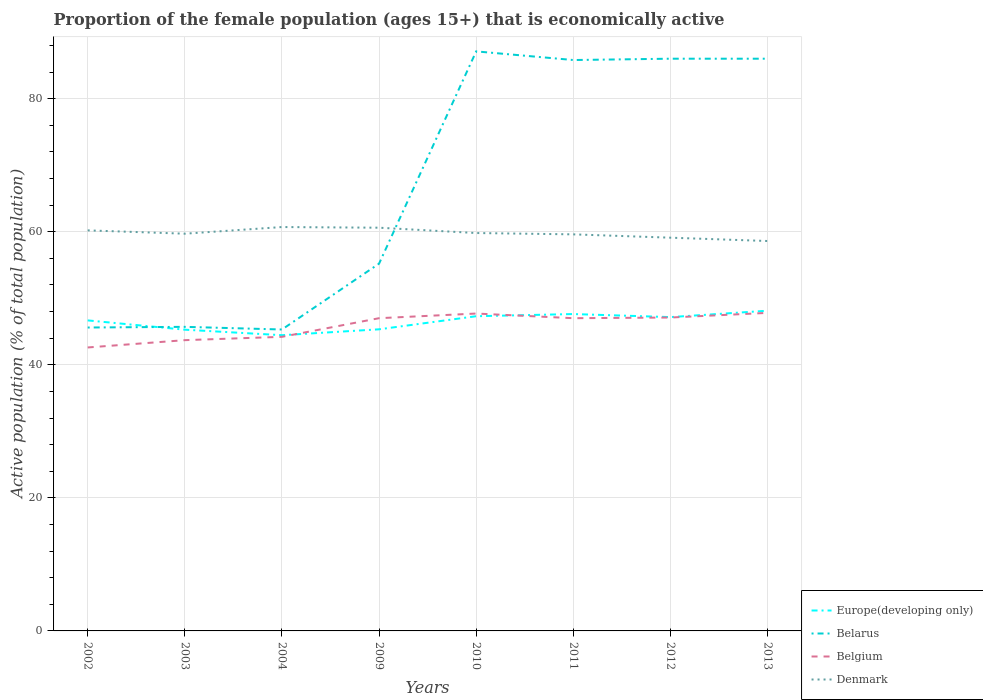Is the number of lines equal to the number of legend labels?
Your response must be concise. Yes. Across all years, what is the maximum proportion of the female population that is economically active in Denmark?
Your response must be concise. 58.6. In which year was the proportion of the female population that is economically active in Europe(developing only) maximum?
Your answer should be compact. 2004. What is the total proportion of the female population that is economically active in Denmark in the graph?
Offer a very short reply. 1.6. What is the difference between the highest and the second highest proportion of the female population that is economically active in Denmark?
Your response must be concise. 2.1. Is the proportion of the female population that is economically active in Belarus strictly greater than the proportion of the female population that is economically active in Denmark over the years?
Your answer should be compact. No. What is the difference between two consecutive major ticks on the Y-axis?
Ensure brevity in your answer.  20. Does the graph contain grids?
Provide a short and direct response. Yes. What is the title of the graph?
Provide a short and direct response. Proportion of the female population (ages 15+) that is economically active. Does "Germany" appear as one of the legend labels in the graph?
Keep it short and to the point. No. What is the label or title of the Y-axis?
Offer a terse response. Active population (% of total population). What is the Active population (% of total population) of Europe(developing only) in 2002?
Keep it short and to the point. 46.67. What is the Active population (% of total population) of Belarus in 2002?
Offer a very short reply. 45.6. What is the Active population (% of total population) in Belgium in 2002?
Offer a very short reply. 42.6. What is the Active population (% of total population) in Denmark in 2002?
Provide a short and direct response. 60.2. What is the Active population (% of total population) of Europe(developing only) in 2003?
Give a very brief answer. 45.27. What is the Active population (% of total population) of Belarus in 2003?
Provide a short and direct response. 45.7. What is the Active population (% of total population) in Belgium in 2003?
Offer a terse response. 43.7. What is the Active population (% of total population) of Denmark in 2003?
Your response must be concise. 59.7. What is the Active population (% of total population) in Europe(developing only) in 2004?
Make the answer very short. 44.45. What is the Active population (% of total population) in Belarus in 2004?
Offer a terse response. 45.3. What is the Active population (% of total population) of Belgium in 2004?
Your answer should be compact. 44.2. What is the Active population (% of total population) in Denmark in 2004?
Your answer should be very brief. 60.7. What is the Active population (% of total population) of Europe(developing only) in 2009?
Your response must be concise. 45.33. What is the Active population (% of total population) of Belarus in 2009?
Offer a very short reply. 55.2. What is the Active population (% of total population) in Denmark in 2009?
Provide a short and direct response. 60.6. What is the Active population (% of total population) in Europe(developing only) in 2010?
Offer a terse response. 47.3. What is the Active population (% of total population) in Belarus in 2010?
Offer a terse response. 87.1. What is the Active population (% of total population) of Belgium in 2010?
Your answer should be very brief. 47.7. What is the Active population (% of total population) in Denmark in 2010?
Your answer should be compact. 59.8. What is the Active population (% of total population) of Europe(developing only) in 2011?
Your answer should be compact. 47.62. What is the Active population (% of total population) in Belarus in 2011?
Provide a succinct answer. 85.8. What is the Active population (% of total population) of Belgium in 2011?
Ensure brevity in your answer.  47. What is the Active population (% of total population) of Denmark in 2011?
Make the answer very short. 59.6. What is the Active population (% of total population) of Europe(developing only) in 2012?
Make the answer very short. 47.16. What is the Active population (% of total population) of Belarus in 2012?
Offer a very short reply. 86. What is the Active population (% of total population) in Belgium in 2012?
Keep it short and to the point. 47.1. What is the Active population (% of total population) of Denmark in 2012?
Provide a succinct answer. 59.1. What is the Active population (% of total population) of Europe(developing only) in 2013?
Offer a very short reply. 48.12. What is the Active population (% of total population) of Belarus in 2013?
Keep it short and to the point. 86. What is the Active population (% of total population) in Belgium in 2013?
Give a very brief answer. 47.8. What is the Active population (% of total population) in Denmark in 2013?
Make the answer very short. 58.6. Across all years, what is the maximum Active population (% of total population) of Europe(developing only)?
Make the answer very short. 48.12. Across all years, what is the maximum Active population (% of total population) in Belarus?
Your response must be concise. 87.1. Across all years, what is the maximum Active population (% of total population) of Belgium?
Give a very brief answer. 47.8. Across all years, what is the maximum Active population (% of total population) of Denmark?
Your answer should be compact. 60.7. Across all years, what is the minimum Active population (% of total population) of Europe(developing only)?
Provide a short and direct response. 44.45. Across all years, what is the minimum Active population (% of total population) in Belarus?
Keep it short and to the point. 45.3. Across all years, what is the minimum Active population (% of total population) in Belgium?
Offer a terse response. 42.6. Across all years, what is the minimum Active population (% of total population) of Denmark?
Provide a succinct answer. 58.6. What is the total Active population (% of total population) of Europe(developing only) in the graph?
Give a very brief answer. 371.93. What is the total Active population (% of total population) in Belarus in the graph?
Make the answer very short. 536.7. What is the total Active population (% of total population) of Belgium in the graph?
Give a very brief answer. 367.1. What is the total Active population (% of total population) of Denmark in the graph?
Offer a terse response. 478.3. What is the difference between the Active population (% of total population) in Europe(developing only) in 2002 and that in 2003?
Ensure brevity in your answer.  1.4. What is the difference between the Active population (% of total population) in Belgium in 2002 and that in 2003?
Keep it short and to the point. -1.1. What is the difference between the Active population (% of total population) in Europe(developing only) in 2002 and that in 2004?
Keep it short and to the point. 2.22. What is the difference between the Active population (% of total population) of Belgium in 2002 and that in 2004?
Provide a succinct answer. -1.6. What is the difference between the Active population (% of total population) of Denmark in 2002 and that in 2004?
Offer a terse response. -0.5. What is the difference between the Active population (% of total population) of Europe(developing only) in 2002 and that in 2009?
Provide a succinct answer. 1.34. What is the difference between the Active population (% of total population) in Belarus in 2002 and that in 2009?
Your answer should be compact. -9.6. What is the difference between the Active population (% of total population) of Denmark in 2002 and that in 2009?
Offer a very short reply. -0.4. What is the difference between the Active population (% of total population) of Europe(developing only) in 2002 and that in 2010?
Give a very brief answer. -0.63. What is the difference between the Active population (% of total population) in Belarus in 2002 and that in 2010?
Offer a very short reply. -41.5. What is the difference between the Active population (% of total population) of Belgium in 2002 and that in 2010?
Provide a short and direct response. -5.1. What is the difference between the Active population (% of total population) in Europe(developing only) in 2002 and that in 2011?
Offer a terse response. -0.95. What is the difference between the Active population (% of total population) in Belarus in 2002 and that in 2011?
Offer a very short reply. -40.2. What is the difference between the Active population (% of total population) in Europe(developing only) in 2002 and that in 2012?
Offer a very short reply. -0.49. What is the difference between the Active population (% of total population) in Belarus in 2002 and that in 2012?
Ensure brevity in your answer.  -40.4. What is the difference between the Active population (% of total population) in Belgium in 2002 and that in 2012?
Provide a succinct answer. -4.5. What is the difference between the Active population (% of total population) in Europe(developing only) in 2002 and that in 2013?
Your response must be concise. -1.46. What is the difference between the Active population (% of total population) of Belarus in 2002 and that in 2013?
Your answer should be very brief. -40.4. What is the difference between the Active population (% of total population) in Europe(developing only) in 2003 and that in 2004?
Your answer should be compact. 0.83. What is the difference between the Active population (% of total population) of Belarus in 2003 and that in 2004?
Give a very brief answer. 0.4. What is the difference between the Active population (% of total population) of Europe(developing only) in 2003 and that in 2009?
Offer a very short reply. -0.06. What is the difference between the Active population (% of total population) in Belarus in 2003 and that in 2009?
Your answer should be very brief. -9.5. What is the difference between the Active population (% of total population) of Belgium in 2003 and that in 2009?
Your response must be concise. -3.3. What is the difference between the Active population (% of total population) in Denmark in 2003 and that in 2009?
Keep it short and to the point. -0.9. What is the difference between the Active population (% of total population) in Europe(developing only) in 2003 and that in 2010?
Your answer should be compact. -2.02. What is the difference between the Active population (% of total population) in Belarus in 2003 and that in 2010?
Your answer should be very brief. -41.4. What is the difference between the Active population (% of total population) in Belgium in 2003 and that in 2010?
Offer a terse response. -4. What is the difference between the Active population (% of total population) in Europe(developing only) in 2003 and that in 2011?
Your answer should be compact. -2.35. What is the difference between the Active population (% of total population) of Belarus in 2003 and that in 2011?
Offer a terse response. -40.1. What is the difference between the Active population (% of total population) of Belgium in 2003 and that in 2011?
Make the answer very short. -3.3. What is the difference between the Active population (% of total population) of Europe(developing only) in 2003 and that in 2012?
Offer a very short reply. -1.89. What is the difference between the Active population (% of total population) of Belarus in 2003 and that in 2012?
Your answer should be compact. -40.3. What is the difference between the Active population (% of total population) in Belgium in 2003 and that in 2012?
Provide a succinct answer. -3.4. What is the difference between the Active population (% of total population) in Europe(developing only) in 2003 and that in 2013?
Make the answer very short. -2.85. What is the difference between the Active population (% of total population) in Belarus in 2003 and that in 2013?
Give a very brief answer. -40.3. What is the difference between the Active population (% of total population) in Belgium in 2003 and that in 2013?
Give a very brief answer. -4.1. What is the difference between the Active population (% of total population) in Europe(developing only) in 2004 and that in 2009?
Offer a terse response. -0.88. What is the difference between the Active population (% of total population) in Denmark in 2004 and that in 2009?
Your answer should be very brief. 0.1. What is the difference between the Active population (% of total population) of Europe(developing only) in 2004 and that in 2010?
Ensure brevity in your answer.  -2.85. What is the difference between the Active population (% of total population) of Belarus in 2004 and that in 2010?
Your answer should be compact. -41.8. What is the difference between the Active population (% of total population) of Belgium in 2004 and that in 2010?
Offer a very short reply. -3.5. What is the difference between the Active population (% of total population) in Europe(developing only) in 2004 and that in 2011?
Keep it short and to the point. -3.18. What is the difference between the Active population (% of total population) of Belarus in 2004 and that in 2011?
Provide a short and direct response. -40.5. What is the difference between the Active population (% of total population) in Denmark in 2004 and that in 2011?
Give a very brief answer. 1.1. What is the difference between the Active population (% of total population) of Europe(developing only) in 2004 and that in 2012?
Keep it short and to the point. -2.72. What is the difference between the Active population (% of total population) in Belarus in 2004 and that in 2012?
Ensure brevity in your answer.  -40.7. What is the difference between the Active population (% of total population) in Belgium in 2004 and that in 2012?
Your response must be concise. -2.9. What is the difference between the Active population (% of total population) of Denmark in 2004 and that in 2012?
Make the answer very short. 1.6. What is the difference between the Active population (% of total population) of Europe(developing only) in 2004 and that in 2013?
Your answer should be compact. -3.68. What is the difference between the Active population (% of total population) in Belarus in 2004 and that in 2013?
Your answer should be compact. -40.7. What is the difference between the Active population (% of total population) in Denmark in 2004 and that in 2013?
Give a very brief answer. 2.1. What is the difference between the Active population (% of total population) of Europe(developing only) in 2009 and that in 2010?
Provide a succinct answer. -1.97. What is the difference between the Active population (% of total population) in Belarus in 2009 and that in 2010?
Ensure brevity in your answer.  -31.9. What is the difference between the Active population (% of total population) in Denmark in 2009 and that in 2010?
Make the answer very short. 0.8. What is the difference between the Active population (% of total population) in Europe(developing only) in 2009 and that in 2011?
Provide a succinct answer. -2.29. What is the difference between the Active population (% of total population) in Belarus in 2009 and that in 2011?
Give a very brief answer. -30.6. What is the difference between the Active population (% of total population) in Denmark in 2009 and that in 2011?
Make the answer very short. 1. What is the difference between the Active population (% of total population) of Europe(developing only) in 2009 and that in 2012?
Offer a terse response. -1.83. What is the difference between the Active population (% of total population) in Belarus in 2009 and that in 2012?
Your response must be concise. -30.8. What is the difference between the Active population (% of total population) in Europe(developing only) in 2009 and that in 2013?
Your answer should be very brief. -2.79. What is the difference between the Active population (% of total population) in Belarus in 2009 and that in 2013?
Offer a terse response. -30.8. What is the difference between the Active population (% of total population) in Belgium in 2009 and that in 2013?
Provide a succinct answer. -0.8. What is the difference between the Active population (% of total population) in Denmark in 2009 and that in 2013?
Your response must be concise. 2. What is the difference between the Active population (% of total population) of Europe(developing only) in 2010 and that in 2011?
Ensure brevity in your answer.  -0.33. What is the difference between the Active population (% of total population) of Belarus in 2010 and that in 2011?
Ensure brevity in your answer.  1.3. What is the difference between the Active population (% of total population) in Denmark in 2010 and that in 2011?
Offer a terse response. 0.2. What is the difference between the Active population (% of total population) in Europe(developing only) in 2010 and that in 2012?
Offer a terse response. 0.13. What is the difference between the Active population (% of total population) in Belgium in 2010 and that in 2012?
Keep it short and to the point. 0.6. What is the difference between the Active population (% of total population) in Denmark in 2010 and that in 2012?
Ensure brevity in your answer.  0.7. What is the difference between the Active population (% of total population) of Europe(developing only) in 2010 and that in 2013?
Your answer should be compact. -0.83. What is the difference between the Active population (% of total population) in Belarus in 2010 and that in 2013?
Provide a short and direct response. 1.1. What is the difference between the Active population (% of total population) of Belgium in 2010 and that in 2013?
Offer a very short reply. -0.1. What is the difference between the Active population (% of total population) in Europe(developing only) in 2011 and that in 2012?
Ensure brevity in your answer.  0.46. What is the difference between the Active population (% of total population) of Belgium in 2011 and that in 2012?
Give a very brief answer. -0.1. What is the difference between the Active population (% of total population) of Europe(developing only) in 2011 and that in 2013?
Provide a succinct answer. -0.5. What is the difference between the Active population (% of total population) of Belarus in 2011 and that in 2013?
Make the answer very short. -0.2. What is the difference between the Active population (% of total population) in Denmark in 2011 and that in 2013?
Ensure brevity in your answer.  1. What is the difference between the Active population (% of total population) in Europe(developing only) in 2012 and that in 2013?
Ensure brevity in your answer.  -0.96. What is the difference between the Active population (% of total population) in Belarus in 2012 and that in 2013?
Ensure brevity in your answer.  0. What is the difference between the Active population (% of total population) of Europe(developing only) in 2002 and the Active population (% of total population) of Belarus in 2003?
Provide a succinct answer. 0.97. What is the difference between the Active population (% of total population) in Europe(developing only) in 2002 and the Active population (% of total population) in Belgium in 2003?
Keep it short and to the point. 2.97. What is the difference between the Active population (% of total population) in Europe(developing only) in 2002 and the Active population (% of total population) in Denmark in 2003?
Provide a short and direct response. -13.03. What is the difference between the Active population (% of total population) in Belarus in 2002 and the Active population (% of total population) in Belgium in 2003?
Your answer should be compact. 1.9. What is the difference between the Active population (% of total population) in Belarus in 2002 and the Active population (% of total population) in Denmark in 2003?
Your answer should be compact. -14.1. What is the difference between the Active population (% of total population) of Belgium in 2002 and the Active population (% of total population) of Denmark in 2003?
Offer a very short reply. -17.1. What is the difference between the Active population (% of total population) of Europe(developing only) in 2002 and the Active population (% of total population) of Belarus in 2004?
Give a very brief answer. 1.37. What is the difference between the Active population (% of total population) of Europe(developing only) in 2002 and the Active population (% of total population) of Belgium in 2004?
Keep it short and to the point. 2.47. What is the difference between the Active population (% of total population) in Europe(developing only) in 2002 and the Active population (% of total population) in Denmark in 2004?
Ensure brevity in your answer.  -14.03. What is the difference between the Active population (% of total population) of Belarus in 2002 and the Active population (% of total population) of Belgium in 2004?
Your answer should be very brief. 1.4. What is the difference between the Active population (% of total population) in Belarus in 2002 and the Active population (% of total population) in Denmark in 2004?
Offer a terse response. -15.1. What is the difference between the Active population (% of total population) in Belgium in 2002 and the Active population (% of total population) in Denmark in 2004?
Provide a succinct answer. -18.1. What is the difference between the Active population (% of total population) in Europe(developing only) in 2002 and the Active population (% of total population) in Belarus in 2009?
Your response must be concise. -8.53. What is the difference between the Active population (% of total population) in Europe(developing only) in 2002 and the Active population (% of total population) in Belgium in 2009?
Make the answer very short. -0.33. What is the difference between the Active population (% of total population) of Europe(developing only) in 2002 and the Active population (% of total population) of Denmark in 2009?
Keep it short and to the point. -13.93. What is the difference between the Active population (% of total population) of Belarus in 2002 and the Active population (% of total population) of Belgium in 2009?
Provide a succinct answer. -1.4. What is the difference between the Active population (% of total population) in Belgium in 2002 and the Active population (% of total population) in Denmark in 2009?
Offer a very short reply. -18. What is the difference between the Active population (% of total population) in Europe(developing only) in 2002 and the Active population (% of total population) in Belarus in 2010?
Offer a terse response. -40.43. What is the difference between the Active population (% of total population) of Europe(developing only) in 2002 and the Active population (% of total population) of Belgium in 2010?
Offer a very short reply. -1.03. What is the difference between the Active population (% of total population) of Europe(developing only) in 2002 and the Active population (% of total population) of Denmark in 2010?
Your response must be concise. -13.13. What is the difference between the Active population (% of total population) of Belarus in 2002 and the Active population (% of total population) of Denmark in 2010?
Provide a succinct answer. -14.2. What is the difference between the Active population (% of total population) in Belgium in 2002 and the Active population (% of total population) in Denmark in 2010?
Provide a succinct answer. -17.2. What is the difference between the Active population (% of total population) in Europe(developing only) in 2002 and the Active population (% of total population) in Belarus in 2011?
Offer a terse response. -39.13. What is the difference between the Active population (% of total population) of Europe(developing only) in 2002 and the Active population (% of total population) of Belgium in 2011?
Your answer should be compact. -0.33. What is the difference between the Active population (% of total population) of Europe(developing only) in 2002 and the Active population (% of total population) of Denmark in 2011?
Give a very brief answer. -12.93. What is the difference between the Active population (% of total population) in Belarus in 2002 and the Active population (% of total population) in Denmark in 2011?
Your answer should be very brief. -14. What is the difference between the Active population (% of total population) of Belgium in 2002 and the Active population (% of total population) of Denmark in 2011?
Keep it short and to the point. -17. What is the difference between the Active population (% of total population) in Europe(developing only) in 2002 and the Active population (% of total population) in Belarus in 2012?
Give a very brief answer. -39.33. What is the difference between the Active population (% of total population) in Europe(developing only) in 2002 and the Active population (% of total population) in Belgium in 2012?
Provide a succinct answer. -0.43. What is the difference between the Active population (% of total population) of Europe(developing only) in 2002 and the Active population (% of total population) of Denmark in 2012?
Your answer should be compact. -12.43. What is the difference between the Active population (% of total population) of Belarus in 2002 and the Active population (% of total population) of Belgium in 2012?
Offer a very short reply. -1.5. What is the difference between the Active population (% of total population) of Belgium in 2002 and the Active population (% of total population) of Denmark in 2012?
Your answer should be very brief. -16.5. What is the difference between the Active population (% of total population) of Europe(developing only) in 2002 and the Active population (% of total population) of Belarus in 2013?
Provide a short and direct response. -39.33. What is the difference between the Active population (% of total population) in Europe(developing only) in 2002 and the Active population (% of total population) in Belgium in 2013?
Provide a succinct answer. -1.13. What is the difference between the Active population (% of total population) of Europe(developing only) in 2002 and the Active population (% of total population) of Denmark in 2013?
Give a very brief answer. -11.93. What is the difference between the Active population (% of total population) of Europe(developing only) in 2003 and the Active population (% of total population) of Belarus in 2004?
Give a very brief answer. -0.03. What is the difference between the Active population (% of total population) in Europe(developing only) in 2003 and the Active population (% of total population) in Belgium in 2004?
Keep it short and to the point. 1.07. What is the difference between the Active population (% of total population) of Europe(developing only) in 2003 and the Active population (% of total population) of Denmark in 2004?
Offer a terse response. -15.43. What is the difference between the Active population (% of total population) in Europe(developing only) in 2003 and the Active population (% of total population) in Belarus in 2009?
Your answer should be very brief. -9.93. What is the difference between the Active population (% of total population) of Europe(developing only) in 2003 and the Active population (% of total population) of Belgium in 2009?
Your answer should be compact. -1.73. What is the difference between the Active population (% of total population) in Europe(developing only) in 2003 and the Active population (% of total population) in Denmark in 2009?
Keep it short and to the point. -15.33. What is the difference between the Active population (% of total population) of Belarus in 2003 and the Active population (% of total population) of Belgium in 2009?
Provide a succinct answer. -1.3. What is the difference between the Active population (% of total population) of Belarus in 2003 and the Active population (% of total population) of Denmark in 2009?
Offer a terse response. -14.9. What is the difference between the Active population (% of total population) of Belgium in 2003 and the Active population (% of total population) of Denmark in 2009?
Ensure brevity in your answer.  -16.9. What is the difference between the Active population (% of total population) of Europe(developing only) in 2003 and the Active population (% of total population) of Belarus in 2010?
Make the answer very short. -41.83. What is the difference between the Active population (% of total population) in Europe(developing only) in 2003 and the Active population (% of total population) in Belgium in 2010?
Offer a very short reply. -2.43. What is the difference between the Active population (% of total population) of Europe(developing only) in 2003 and the Active population (% of total population) of Denmark in 2010?
Provide a succinct answer. -14.53. What is the difference between the Active population (% of total population) of Belarus in 2003 and the Active population (% of total population) of Belgium in 2010?
Offer a terse response. -2. What is the difference between the Active population (% of total population) of Belarus in 2003 and the Active population (% of total population) of Denmark in 2010?
Give a very brief answer. -14.1. What is the difference between the Active population (% of total population) in Belgium in 2003 and the Active population (% of total population) in Denmark in 2010?
Provide a short and direct response. -16.1. What is the difference between the Active population (% of total population) in Europe(developing only) in 2003 and the Active population (% of total population) in Belarus in 2011?
Give a very brief answer. -40.53. What is the difference between the Active population (% of total population) in Europe(developing only) in 2003 and the Active population (% of total population) in Belgium in 2011?
Keep it short and to the point. -1.73. What is the difference between the Active population (% of total population) in Europe(developing only) in 2003 and the Active population (% of total population) in Denmark in 2011?
Your answer should be compact. -14.33. What is the difference between the Active population (% of total population) of Belarus in 2003 and the Active population (% of total population) of Denmark in 2011?
Provide a short and direct response. -13.9. What is the difference between the Active population (% of total population) in Belgium in 2003 and the Active population (% of total population) in Denmark in 2011?
Keep it short and to the point. -15.9. What is the difference between the Active population (% of total population) in Europe(developing only) in 2003 and the Active population (% of total population) in Belarus in 2012?
Ensure brevity in your answer.  -40.73. What is the difference between the Active population (% of total population) in Europe(developing only) in 2003 and the Active population (% of total population) in Belgium in 2012?
Keep it short and to the point. -1.83. What is the difference between the Active population (% of total population) in Europe(developing only) in 2003 and the Active population (% of total population) in Denmark in 2012?
Offer a terse response. -13.83. What is the difference between the Active population (% of total population) of Belarus in 2003 and the Active population (% of total population) of Denmark in 2012?
Offer a terse response. -13.4. What is the difference between the Active population (% of total population) of Belgium in 2003 and the Active population (% of total population) of Denmark in 2012?
Offer a terse response. -15.4. What is the difference between the Active population (% of total population) in Europe(developing only) in 2003 and the Active population (% of total population) in Belarus in 2013?
Your answer should be compact. -40.73. What is the difference between the Active population (% of total population) of Europe(developing only) in 2003 and the Active population (% of total population) of Belgium in 2013?
Offer a terse response. -2.53. What is the difference between the Active population (% of total population) in Europe(developing only) in 2003 and the Active population (% of total population) in Denmark in 2013?
Make the answer very short. -13.33. What is the difference between the Active population (% of total population) of Belarus in 2003 and the Active population (% of total population) of Belgium in 2013?
Your answer should be compact. -2.1. What is the difference between the Active population (% of total population) of Belgium in 2003 and the Active population (% of total population) of Denmark in 2013?
Make the answer very short. -14.9. What is the difference between the Active population (% of total population) of Europe(developing only) in 2004 and the Active population (% of total population) of Belarus in 2009?
Provide a succinct answer. -10.75. What is the difference between the Active population (% of total population) of Europe(developing only) in 2004 and the Active population (% of total population) of Belgium in 2009?
Keep it short and to the point. -2.55. What is the difference between the Active population (% of total population) of Europe(developing only) in 2004 and the Active population (% of total population) of Denmark in 2009?
Ensure brevity in your answer.  -16.15. What is the difference between the Active population (% of total population) of Belarus in 2004 and the Active population (% of total population) of Belgium in 2009?
Provide a short and direct response. -1.7. What is the difference between the Active population (% of total population) in Belarus in 2004 and the Active population (% of total population) in Denmark in 2009?
Offer a terse response. -15.3. What is the difference between the Active population (% of total population) of Belgium in 2004 and the Active population (% of total population) of Denmark in 2009?
Provide a short and direct response. -16.4. What is the difference between the Active population (% of total population) in Europe(developing only) in 2004 and the Active population (% of total population) in Belarus in 2010?
Your answer should be very brief. -42.65. What is the difference between the Active population (% of total population) in Europe(developing only) in 2004 and the Active population (% of total population) in Belgium in 2010?
Your answer should be very brief. -3.25. What is the difference between the Active population (% of total population) in Europe(developing only) in 2004 and the Active population (% of total population) in Denmark in 2010?
Provide a short and direct response. -15.35. What is the difference between the Active population (% of total population) of Belgium in 2004 and the Active population (% of total population) of Denmark in 2010?
Offer a terse response. -15.6. What is the difference between the Active population (% of total population) of Europe(developing only) in 2004 and the Active population (% of total population) of Belarus in 2011?
Keep it short and to the point. -41.35. What is the difference between the Active population (% of total population) in Europe(developing only) in 2004 and the Active population (% of total population) in Belgium in 2011?
Make the answer very short. -2.55. What is the difference between the Active population (% of total population) in Europe(developing only) in 2004 and the Active population (% of total population) in Denmark in 2011?
Your answer should be compact. -15.15. What is the difference between the Active population (% of total population) in Belarus in 2004 and the Active population (% of total population) in Denmark in 2011?
Offer a very short reply. -14.3. What is the difference between the Active population (% of total population) in Belgium in 2004 and the Active population (% of total population) in Denmark in 2011?
Offer a very short reply. -15.4. What is the difference between the Active population (% of total population) in Europe(developing only) in 2004 and the Active population (% of total population) in Belarus in 2012?
Your answer should be compact. -41.55. What is the difference between the Active population (% of total population) in Europe(developing only) in 2004 and the Active population (% of total population) in Belgium in 2012?
Offer a terse response. -2.65. What is the difference between the Active population (% of total population) of Europe(developing only) in 2004 and the Active population (% of total population) of Denmark in 2012?
Provide a succinct answer. -14.65. What is the difference between the Active population (% of total population) of Belarus in 2004 and the Active population (% of total population) of Denmark in 2012?
Give a very brief answer. -13.8. What is the difference between the Active population (% of total population) in Belgium in 2004 and the Active population (% of total population) in Denmark in 2012?
Provide a succinct answer. -14.9. What is the difference between the Active population (% of total population) of Europe(developing only) in 2004 and the Active population (% of total population) of Belarus in 2013?
Your answer should be compact. -41.55. What is the difference between the Active population (% of total population) of Europe(developing only) in 2004 and the Active population (% of total population) of Belgium in 2013?
Give a very brief answer. -3.35. What is the difference between the Active population (% of total population) of Europe(developing only) in 2004 and the Active population (% of total population) of Denmark in 2013?
Keep it short and to the point. -14.15. What is the difference between the Active population (% of total population) of Belarus in 2004 and the Active population (% of total population) of Belgium in 2013?
Ensure brevity in your answer.  -2.5. What is the difference between the Active population (% of total population) of Belgium in 2004 and the Active population (% of total population) of Denmark in 2013?
Keep it short and to the point. -14.4. What is the difference between the Active population (% of total population) in Europe(developing only) in 2009 and the Active population (% of total population) in Belarus in 2010?
Offer a terse response. -41.77. What is the difference between the Active population (% of total population) in Europe(developing only) in 2009 and the Active population (% of total population) in Belgium in 2010?
Provide a succinct answer. -2.37. What is the difference between the Active population (% of total population) in Europe(developing only) in 2009 and the Active population (% of total population) in Denmark in 2010?
Ensure brevity in your answer.  -14.47. What is the difference between the Active population (% of total population) in Europe(developing only) in 2009 and the Active population (% of total population) in Belarus in 2011?
Make the answer very short. -40.47. What is the difference between the Active population (% of total population) in Europe(developing only) in 2009 and the Active population (% of total population) in Belgium in 2011?
Your answer should be compact. -1.67. What is the difference between the Active population (% of total population) in Europe(developing only) in 2009 and the Active population (% of total population) in Denmark in 2011?
Your answer should be compact. -14.27. What is the difference between the Active population (% of total population) in Belarus in 2009 and the Active population (% of total population) in Belgium in 2011?
Your answer should be compact. 8.2. What is the difference between the Active population (% of total population) of Belgium in 2009 and the Active population (% of total population) of Denmark in 2011?
Ensure brevity in your answer.  -12.6. What is the difference between the Active population (% of total population) of Europe(developing only) in 2009 and the Active population (% of total population) of Belarus in 2012?
Your answer should be very brief. -40.67. What is the difference between the Active population (% of total population) in Europe(developing only) in 2009 and the Active population (% of total population) in Belgium in 2012?
Your response must be concise. -1.77. What is the difference between the Active population (% of total population) of Europe(developing only) in 2009 and the Active population (% of total population) of Denmark in 2012?
Your answer should be very brief. -13.77. What is the difference between the Active population (% of total population) in Belarus in 2009 and the Active population (% of total population) in Belgium in 2012?
Make the answer very short. 8.1. What is the difference between the Active population (% of total population) in Europe(developing only) in 2009 and the Active population (% of total population) in Belarus in 2013?
Make the answer very short. -40.67. What is the difference between the Active population (% of total population) of Europe(developing only) in 2009 and the Active population (% of total population) of Belgium in 2013?
Keep it short and to the point. -2.47. What is the difference between the Active population (% of total population) of Europe(developing only) in 2009 and the Active population (% of total population) of Denmark in 2013?
Keep it short and to the point. -13.27. What is the difference between the Active population (% of total population) of Belarus in 2009 and the Active population (% of total population) of Belgium in 2013?
Keep it short and to the point. 7.4. What is the difference between the Active population (% of total population) of Belgium in 2009 and the Active population (% of total population) of Denmark in 2013?
Offer a terse response. -11.6. What is the difference between the Active population (% of total population) of Europe(developing only) in 2010 and the Active population (% of total population) of Belarus in 2011?
Offer a terse response. -38.5. What is the difference between the Active population (% of total population) in Europe(developing only) in 2010 and the Active population (% of total population) in Belgium in 2011?
Offer a terse response. 0.3. What is the difference between the Active population (% of total population) of Europe(developing only) in 2010 and the Active population (% of total population) of Denmark in 2011?
Your response must be concise. -12.3. What is the difference between the Active population (% of total population) in Belarus in 2010 and the Active population (% of total population) in Belgium in 2011?
Provide a succinct answer. 40.1. What is the difference between the Active population (% of total population) in Belarus in 2010 and the Active population (% of total population) in Denmark in 2011?
Your response must be concise. 27.5. What is the difference between the Active population (% of total population) of Belgium in 2010 and the Active population (% of total population) of Denmark in 2011?
Offer a very short reply. -11.9. What is the difference between the Active population (% of total population) of Europe(developing only) in 2010 and the Active population (% of total population) of Belarus in 2012?
Offer a terse response. -38.7. What is the difference between the Active population (% of total population) of Europe(developing only) in 2010 and the Active population (% of total population) of Belgium in 2012?
Your answer should be compact. 0.2. What is the difference between the Active population (% of total population) of Europe(developing only) in 2010 and the Active population (% of total population) of Denmark in 2012?
Your answer should be very brief. -11.8. What is the difference between the Active population (% of total population) in Belarus in 2010 and the Active population (% of total population) in Belgium in 2012?
Give a very brief answer. 40. What is the difference between the Active population (% of total population) in Europe(developing only) in 2010 and the Active population (% of total population) in Belarus in 2013?
Provide a short and direct response. -38.7. What is the difference between the Active population (% of total population) in Europe(developing only) in 2010 and the Active population (% of total population) in Belgium in 2013?
Provide a succinct answer. -0.5. What is the difference between the Active population (% of total population) of Europe(developing only) in 2010 and the Active population (% of total population) of Denmark in 2013?
Ensure brevity in your answer.  -11.3. What is the difference between the Active population (% of total population) in Belarus in 2010 and the Active population (% of total population) in Belgium in 2013?
Make the answer very short. 39.3. What is the difference between the Active population (% of total population) of Belarus in 2010 and the Active population (% of total population) of Denmark in 2013?
Offer a terse response. 28.5. What is the difference between the Active population (% of total population) in Europe(developing only) in 2011 and the Active population (% of total population) in Belarus in 2012?
Keep it short and to the point. -38.38. What is the difference between the Active population (% of total population) of Europe(developing only) in 2011 and the Active population (% of total population) of Belgium in 2012?
Provide a succinct answer. 0.52. What is the difference between the Active population (% of total population) in Europe(developing only) in 2011 and the Active population (% of total population) in Denmark in 2012?
Provide a succinct answer. -11.48. What is the difference between the Active population (% of total population) of Belarus in 2011 and the Active population (% of total population) of Belgium in 2012?
Give a very brief answer. 38.7. What is the difference between the Active population (% of total population) of Belarus in 2011 and the Active population (% of total population) of Denmark in 2012?
Make the answer very short. 26.7. What is the difference between the Active population (% of total population) of Europe(developing only) in 2011 and the Active population (% of total population) of Belarus in 2013?
Your response must be concise. -38.38. What is the difference between the Active population (% of total population) in Europe(developing only) in 2011 and the Active population (% of total population) in Belgium in 2013?
Provide a succinct answer. -0.18. What is the difference between the Active population (% of total population) of Europe(developing only) in 2011 and the Active population (% of total population) of Denmark in 2013?
Provide a short and direct response. -10.98. What is the difference between the Active population (% of total population) of Belarus in 2011 and the Active population (% of total population) of Belgium in 2013?
Your answer should be very brief. 38. What is the difference between the Active population (% of total population) in Belarus in 2011 and the Active population (% of total population) in Denmark in 2013?
Make the answer very short. 27.2. What is the difference between the Active population (% of total population) of Europe(developing only) in 2012 and the Active population (% of total population) of Belarus in 2013?
Ensure brevity in your answer.  -38.84. What is the difference between the Active population (% of total population) of Europe(developing only) in 2012 and the Active population (% of total population) of Belgium in 2013?
Give a very brief answer. -0.64. What is the difference between the Active population (% of total population) in Europe(developing only) in 2012 and the Active population (% of total population) in Denmark in 2013?
Offer a terse response. -11.44. What is the difference between the Active population (% of total population) in Belarus in 2012 and the Active population (% of total population) in Belgium in 2013?
Your answer should be very brief. 38.2. What is the difference between the Active population (% of total population) in Belarus in 2012 and the Active population (% of total population) in Denmark in 2013?
Provide a succinct answer. 27.4. What is the average Active population (% of total population) of Europe(developing only) per year?
Provide a short and direct response. 46.49. What is the average Active population (% of total population) of Belarus per year?
Provide a short and direct response. 67.09. What is the average Active population (% of total population) in Belgium per year?
Give a very brief answer. 45.89. What is the average Active population (% of total population) of Denmark per year?
Your response must be concise. 59.79. In the year 2002, what is the difference between the Active population (% of total population) in Europe(developing only) and Active population (% of total population) in Belarus?
Ensure brevity in your answer.  1.07. In the year 2002, what is the difference between the Active population (% of total population) of Europe(developing only) and Active population (% of total population) of Belgium?
Make the answer very short. 4.07. In the year 2002, what is the difference between the Active population (% of total population) in Europe(developing only) and Active population (% of total population) in Denmark?
Give a very brief answer. -13.53. In the year 2002, what is the difference between the Active population (% of total population) of Belarus and Active population (% of total population) of Belgium?
Offer a very short reply. 3. In the year 2002, what is the difference between the Active population (% of total population) in Belarus and Active population (% of total population) in Denmark?
Provide a short and direct response. -14.6. In the year 2002, what is the difference between the Active population (% of total population) in Belgium and Active population (% of total population) in Denmark?
Make the answer very short. -17.6. In the year 2003, what is the difference between the Active population (% of total population) of Europe(developing only) and Active population (% of total population) of Belarus?
Offer a very short reply. -0.43. In the year 2003, what is the difference between the Active population (% of total population) of Europe(developing only) and Active population (% of total population) of Belgium?
Your answer should be very brief. 1.57. In the year 2003, what is the difference between the Active population (% of total population) of Europe(developing only) and Active population (% of total population) of Denmark?
Ensure brevity in your answer.  -14.43. In the year 2003, what is the difference between the Active population (% of total population) of Belarus and Active population (% of total population) of Belgium?
Provide a short and direct response. 2. In the year 2004, what is the difference between the Active population (% of total population) of Europe(developing only) and Active population (% of total population) of Belarus?
Give a very brief answer. -0.85. In the year 2004, what is the difference between the Active population (% of total population) in Europe(developing only) and Active population (% of total population) in Belgium?
Your answer should be compact. 0.25. In the year 2004, what is the difference between the Active population (% of total population) of Europe(developing only) and Active population (% of total population) of Denmark?
Ensure brevity in your answer.  -16.25. In the year 2004, what is the difference between the Active population (% of total population) in Belarus and Active population (% of total population) in Denmark?
Give a very brief answer. -15.4. In the year 2004, what is the difference between the Active population (% of total population) of Belgium and Active population (% of total population) of Denmark?
Give a very brief answer. -16.5. In the year 2009, what is the difference between the Active population (% of total population) in Europe(developing only) and Active population (% of total population) in Belarus?
Give a very brief answer. -9.87. In the year 2009, what is the difference between the Active population (% of total population) of Europe(developing only) and Active population (% of total population) of Belgium?
Offer a very short reply. -1.67. In the year 2009, what is the difference between the Active population (% of total population) of Europe(developing only) and Active population (% of total population) of Denmark?
Provide a short and direct response. -15.27. In the year 2009, what is the difference between the Active population (% of total population) of Belarus and Active population (% of total population) of Belgium?
Offer a terse response. 8.2. In the year 2009, what is the difference between the Active population (% of total population) in Belgium and Active population (% of total population) in Denmark?
Give a very brief answer. -13.6. In the year 2010, what is the difference between the Active population (% of total population) of Europe(developing only) and Active population (% of total population) of Belarus?
Offer a very short reply. -39.8. In the year 2010, what is the difference between the Active population (% of total population) in Europe(developing only) and Active population (% of total population) in Belgium?
Your answer should be very brief. -0.4. In the year 2010, what is the difference between the Active population (% of total population) in Europe(developing only) and Active population (% of total population) in Denmark?
Make the answer very short. -12.5. In the year 2010, what is the difference between the Active population (% of total population) in Belarus and Active population (% of total population) in Belgium?
Your response must be concise. 39.4. In the year 2010, what is the difference between the Active population (% of total population) in Belarus and Active population (% of total population) in Denmark?
Your response must be concise. 27.3. In the year 2011, what is the difference between the Active population (% of total population) of Europe(developing only) and Active population (% of total population) of Belarus?
Provide a succinct answer. -38.18. In the year 2011, what is the difference between the Active population (% of total population) of Europe(developing only) and Active population (% of total population) of Belgium?
Provide a short and direct response. 0.62. In the year 2011, what is the difference between the Active population (% of total population) of Europe(developing only) and Active population (% of total population) of Denmark?
Make the answer very short. -11.98. In the year 2011, what is the difference between the Active population (% of total population) in Belarus and Active population (% of total population) in Belgium?
Offer a terse response. 38.8. In the year 2011, what is the difference between the Active population (% of total population) of Belarus and Active population (% of total population) of Denmark?
Give a very brief answer. 26.2. In the year 2012, what is the difference between the Active population (% of total population) of Europe(developing only) and Active population (% of total population) of Belarus?
Keep it short and to the point. -38.84. In the year 2012, what is the difference between the Active population (% of total population) of Europe(developing only) and Active population (% of total population) of Belgium?
Provide a short and direct response. 0.06. In the year 2012, what is the difference between the Active population (% of total population) in Europe(developing only) and Active population (% of total population) in Denmark?
Make the answer very short. -11.94. In the year 2012, what is the difference between the Active population (% of total population) in Belarus and Active population (% of total population) in Belgium?
Your answer should be compact. 38.9. In the year 2012, what is the difference between the Active population (% of total population) of Belarus and Active population (% of total population) of Denmark?
Ensure brevity in your answer.  26.9. In the year 2013, what is the difference between the Active population (% of total population) in Europe(developing only) and Active population (% of total population) in Belarus?
Your answer should be very brief. -37.88. In the year 2013, what is the difference between the Active population (% of total population) in Europe(developing only) and Active population (% of total population) in Belgium?
Provide a succinct answer. 0.32. In the year 2013, what is the difference between the Active population (% of total population) in Europe(developing only) and Active population (% of total population) in Denmark?
Give a very brief answer. -10.48. In the year 2013, what is the difference between the Active population (% of total population) in Belarus and Active population (% of total population) in Belgium?
Offer a very short reply. 38.2. In the year 2013, what is the difference between the Active population (% of total population) in Belarus and Active population (% of total population) in Denmark?
Provide a succinct answer. 27.4. In the year 2013, what is the difference between the Active population (% of total population) in Belgium and Active population (% of total population) in Denmark?
Give a very brief answer. -10.8. What is the ratio of the Active population (% of total population) of Europe(developing only) in 2002 to that in 2003?
Offer a very short reply. 1.03. What is the ratio of the Active population (% of total population) of Belgium in 2002 to that in 2003?
Your answer should be very brief. 0.97. What is the ratio of the Active population (% of total population) of Denmark in 2002 to that in 2003?
Give a very brief answer. 1.01. What is the ratio of the Active population (% of total population) in Europe(developing only) in 2002 to that in 2004?
Give a very brief answer. 1.05. What is the ratio of the Active population (% of total population) of Belarus in 2002 to that in 2004?
Give a very brief answer. 1.01. What is the ratio of the Active population (% of total population) in Belgium in 2002 to that in 2004?
Provide a succinct answer. 0.96. What is the ratio of the Active population (% of total population) of Europe(developing only) in 2002 to that in 2009?
Keep it short and to the point. 1.03. What is the ratio of the Active population (% of total population) of Belarus in 2002 to that in 2009?
Provide a succinct answer. 0.83. What is the ratio of the Active population (% of total population) of Belgium in 2002 to that in 2009?
Offer a very short reply. 0.91. What is the ratio of the Active population (% of total population) of Europe(developing only) in 2002 to that in 2010?
Offer a very short reply. 0.99. What is the ratio of the Active population (% of total population) of Belarus in 2002 to that in 2010?
Give a very brief answer. 0.52. What is the ratio of the Active population (% of total population) in Belgium in 2002 to that in 2010?
Your answer should be compact. 0.89. What is the ratio of the Active population (% of total population) in Denmark in 2002 to that in 2010?
Offer a very short reply. 1.01. What is the ratio of the Active population (% of total population) in Belarus in 2002 to that in 2011?
Provide a succinct answer. 0.53. What is the ratio of the Active population (% of total population) of Belgium in 2002 to that in 2011?
Make the answer very short. 0.91. What is the ratio of the Active population (% of total population) in Europe(developing only) in 2002 to that in 2012?
Your answer should be very brief. 0.99. What is the ratio of the Active population (% of total population) in Belarus in 2002 to that in 2012?
Provide a short and direct response. 0.53. What is the ratio of the Active population (% of total population) of Belgium in 2002 to that in 2012?
Ensure brevity in your answer.  0.9. What is the ratio of the Active population (% of total population) of Denmark in 2002 to that in 2012?
Your answer should be very brief. 1.02. What is the ratio of the Active population (% of total population) of Europe(developing only) in 2002 to that in 2013?
Your answer should be very brief. 0.97. What is the ratio of the Active population (% of total population) in Belarus in 2002 to that in 2013?
Your answer should be very brief. 0.53. What is the ratio of the Active population (% of total population) of Belgium in 2002 to that in 2013?
Give a very brief answer. 0.89. What is the ratio of the Active population (% of total population) in Denmark in 2002 to that in 2013?
Provide a succinct answer. 1.03. What is the ratio of the Active population (% of total population) in Europe(developing only) in 2003 to that in 2004?
Offer a terse response. 1.02. What is the ratio of the Active population (% of total population) of Belarus in 2003 to that in 2004?
Provide a short and direct response. 1.01. What is the ratio of the Active population (% of total population) in Belgium in 2003 to that in 2004?
Provide a short and direct response. 0.99. What is the ratio of the Active population (% of total population) of Denmark in 2003 to that in 2004?
Your response must be concise. 0.98. What is the ratio of the Active population (% of total population) in Belarus in 2003 to that in 2009?
Your answer should be very brief. 0.83. What is the ratio of the Active population (% of total population) in Belgium in 2003 to that in 2009?
Provide a short and direct response. 0.93. What is the ratio of the Active population (% of total population) of Denmark in 2003 to that in 2009?
Make the answer very short. 0.99. What is the ratio of the Active population (% of total population) of Europe(developing only) in 2003 to that in 2010?
Your answer should be very brief. 0.96. What is the ratio of the Active population (% of total population) in Belarus in 2003 to that in 2010?
Make the answer very short. 0.52. What is the ratio of the Active population (% of total population) of Belgium in 2003 to that in 2010?
Your answer should be very brief. 0.92. What is the ratio of the Active population (% of total population) of Denmark in 2003 to that in 2010?
Your answer should be compact. 1. What is the ratio of the Active population (% of total population) of Europe(developing only) in 2003 to that in 2011?
Your response must be concise. 0.95. What is the ratio of the Active population (% of total population) of Belarus in 2003 to that in 2011?
Your answer should be compact. 0.53. What is the ratio of the Active population (% of total population) of Belgium in 2003 to that in 2011?
Your answer should be compact. 0.93. What is the ratio of the Active population (% of total population) in Europe(developing only) in 2003 to that in 2012?
Your answer should be very brief. 0.96. What is the ratio of the Active population (% of total population) in Belarus in 2003 to that in 2012?
Provide a succinct answer. 0.53. What is the ratio of the Active population (% of total population) of Belgium in 2003 to that in 2012?
Your answer should be compact. 0.93. What is the ratio of the Active population (% of total population) in Denmark in 2003 to that in 2012?
Offer a very short reply. 1.01. What is the ratio of the Active population (% of total population) of Europe(developing only) in 2003 to that in 2013?
Offer a terse response. 0.94. What is the ratio of the Active population (% of total population) in Belarus in 2003 to that in 2013?
Provide a short and direct response. 0.53. What is the ratio of the Active population (% of total population) in Belgium in 2003 to that in 2013?
Provide a succinct answer. 0.91. What is the ratio of the Active population (% of total population) of Denmark in 2003 to that in 2013?
Your answer should be compact. 1.02. What is the ratio of the Active population (% of total population) of Europe(developing only) in 2004 to that in 2009?
Make the answer very short. 0.98. What is the ratio of the Active population (% of total population) in Belarus in 2004 to that in 2009?
Your response must be concise. 0.82. What is the ratio of the Active population (% of total population) of Belgium in 2004 to that in 2009?
Keep it short and to the point. 0.94. What is the ratio of the Active population (% of total population) in Denmark in 2004 to that in 2009?
Make the answer very short. 1. What is the ratio of the Active population (% of total population) of Europe(developing only) in 2004 to that in 2010?
Make the answer very short. 0.94. What is the ratio of the Active population (% of total population) in Belarus in 2004 to that in 2010?
Your response must be concise. 0.52. What is the ratio of the Active population (% of total population) of Belgium in 2004 to that in 2010?
Your answer should be compact. 0.93. What is the ratio of the Active population (% of total population) of Denmark in 2004 to that in 2010?
Your response must be concise. 1.02. What is the ratio of the Active population (% of total population) of Europe(developing only) in 2004 to that in 2011?
Your answer should be very brief. 0.93. What is the ratio of the Active population (% of total population) of Belarus in 2004 to that in 2011?
Offer a terse response. 0.53. What is the ratio of the Active population (% of total population) of Belgium in 2004 to that in 2011?
Provide a succinct answer. 0.94. What is the ratio of the Active population (% of total population) in Denmark in 2004 to that in 2011?
Offer a terse response. 1.02. What is the ratio of the Active population (% of total population) in Europe(developing only) in 2004 to that in 2012?
Offer a terse response. 0.94. What is the ratio of the Active population (% of total population) of Belarus in 2004 to that in 2012?
Offer a terse response. 0.53. What is the ratio of the Active population (% of total population) in Belgium in 2004 to that in 2012?
Make the answer very short. 0.94. What is the ratio of the Active population (% of total population) of Denmark in 2004 to that in 2012?
Offer a very short reply. 1.03. What is the ratio of the Active population (% of total population) in Europe(developing only) in 2004 to that in 2013?
Your answer should be very brief. 0.92. What is the ratio of the Active population (% of total population) in Belarus in 2004 to that in 2013?
Offer a very short reply. 0.53. What is the ratio of the Active population (% of total population) of Belgium in 2004 to that in 2013?
Provide a succinct answer. 0.92. What is the ratio of the Active population (% of total population) of Denmark in 2004 to that in 2013?
Offer a very short reply. 1.04. What is the ratio of the Active population (% of total population) of Europe(developing only) in 2009 to that in 2010?
Give a very brief answer. 0.96. What is the ratio of the Active population (% of total population) in Belarus in 2009 to that in 2010?
Ensure brevity in your answer.  0.63. What is the ratio of the Active population (% of total population) of Denmark in 2009 to that in 2010?
Keep it short and to the point. 1.01. What is the ratio of the Active population (% of total population) of Europe(developing only) in 2009 to that in 2011?
Ensure brevity in your answer.  0.95. What is the ratio of the Active population (% of total population) in Belarus in 2009 to that in 2011?
Offer a terse response. 0.64. What is the ratio of the Active population (% of total population) of Denmark in 2009 to that in 2011?
Keep it short and to the point. 1.02. What is the ratio of the Active population (% of total population) in Europe(developing only) in 2009 to that in 2012?
Give a very brief answer. 0.96. What is the ratio of the Active population (% of total population) of Belarus in 2009 to that in 2012?
Your answer should be compact. 0.64. What is the ratio of the Active population (% of total population) of Denmark in 2009 to that in 2012?
Provide a succinct answer. 1.03. What is the ratio of the Active population (% of total population) of Europe(developing only) in 2009 to that in 2013?
Make the answer very short. 0.94. What is the ratio of the Active population (% of total population) in Belarus in 2009 to that in 2013?
Keep it short and to the point. 0.64. What is the ratio of the Active population (% of total population) of Belgium in 2009 to that in 2013?
Keep it short and to the point. 0.98. What is the ratio of the Active population (% of total population) of Denmark in 2009 to that in 2013?
Offer a terse response. 1.03. What is the ratio of the Active population (% of total population) in Europe(developing only) in 2010 to that in 2011?
Keep it short and to the point. 0.99. What is the ratio of the Active population (% of total population) in Belarus in 2010 to that in 2011?
Offer a terse response. 1.02. What is the ratio of the Active population (% of total population) of Belgium in 2010 to that in 2011?
Offer a very short reply. 1.01. What is the ratio of the Active population (% of total population) of Denmark in 2010 to that in 2011?
Make the answer very short. 1. What is the ratio of the Active population (% of total population) in Belarus in 2010 to that in 2012?
Offer a very short reply. 1.01. What is the ratio of the Active population (% of total population) in Belgium in 2010 to that in 2012?
Offer a very short reply. 1.01. What is the ratio of the Active population (% of total population) of Denmark in 2010 to that in 2012?
Offer a terse response. 1.01. What is the ratio of the Active population (% of total population) in Europe(developing only) in 2010 to that in 2013?
Offer a very short reply. 0.98. What is the ratio of the Active population (% of total population) in Belarus in 2010 to that in 2013?
Keep it short and to the point. 1.01. What is the ratio of the Active population (% of total population) in Belgium in 2010 to that in 2013?
Provide a short and direct response. 1. What is the ratio of the Active population (% of total population) in Denmark in 2010 to that in 2013?
Ensure brevity in your answer.  1.02. What is the ratio of the Active population (% of total population) in Europe(developing only) in 2011 to that in 2012?
Give a very brief answer. 1.01. What is the ratio of the Active population (% of total population) in Belarus in 2011 to that in 2012?
Offer a terse response. 1. What is the ratio of the Active population (% of total population) in Belgium in 2011 to that in 2012?
Your answer should be compact. 1. What is the ratio of the Active population (% of total population) in Denmark in 2011 to that in 2012?
Offer a very short reply. 1.01. What is the ratio of the Active population (% of total population) in Belarus in 2011 to that in 2013?
Your answer should be compact. 1. What is the ratio of the Active population (% of total population) of Belgium in 2011 to that in 2013?
Your response must be concise. 0.98. What is the ratio of the Active population (% of total population) of Denmark in 2011 to that in 2013?
Provide a succinct answer. 1.02. What is the ratio of the Active population (% of total population) of Europe(developing only) in 2012 to that in 2013?
Offer a terse response. 0.98. What is the ratio of the Active population (% of total population) in Belarus in 2012 to that in 2013?
Offer a very short reply. 1. What is the ratio of the Active population (% of total population) of Belgium in 2012 to that in 2013?
Provide a short and direct response. 0.99. What is the ratio of the Active population (% of total population) of Denmark in 2012 to that in 2013?
Your answer should be compact. 1.01. What is the difference between the highest and the second highest Active population (% of total population) of Europe(developing only)?
Keep it short and to the point. 0.5. What is the difference between the highest and the second highest Active population (% of total population) in Belarus?
Offer a terse response. 1.1. What is the difference between the highest and the second highest Active population (% of total population) of Belgium?
Provide a short and direct response. 0.1. What is the difference between the highest and the second highest Active population (% of total population) in Denmark?
Offer a terse response. 0.1. What is the difference between the highest and the lowest Active population (% of total population) of Europe(developing only)?
Offer a very short reply. 3.68. What is the difference between the highest and the lowest Active population (% of total population) of Belarus?
Give a very brief answer. 41.8. What is the difference between the highest and the lowest Active population (% of total population) in Denmark?
Keep it short and to the point. 2.1. 